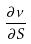<formula> <loc_0><loc_0><loc_500><loc_500>\frac { \partial \nu } { \partial S }</formula> 